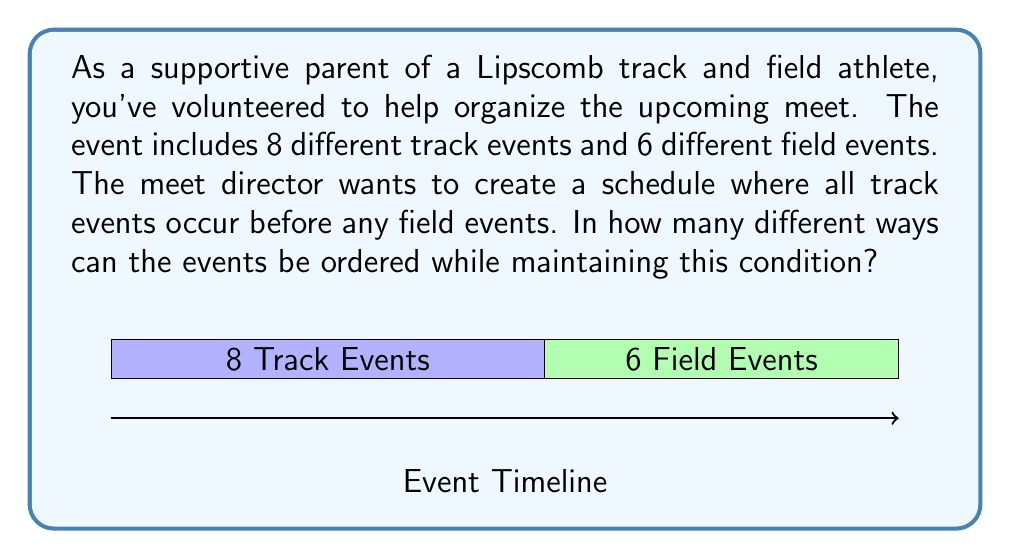Solve this math problem. Let's approach this step-by-step:

1) We need to arrange 8 track events followed by 6 field events.

2) This is a permutation problem, as the order matters.

3) For the track events:
   - We have 8 events to arrange
   - The number of ways to arrange 8 events is 8! (8 factorial)

4) For the field events:
   - We have 6 events to arrange
   - The number of ways to arrange 6 events is 6! (6 factorial)

5) According to the Multiplication Principle, if we have two independent events, we multiply their individual probabilities to get the total number of outcomes.

6) Therefore, the total number of different schedules is:

   $$8! \times 6!$$

7) Let's calculate this:
   $$8! \times 6! = (8 \times 7 \times 6 \times 5 \times 4 \times 3 \times 2 \times 1) \times (6 \times 5 \times 4 \times 3 \times 2 \times 1)$$
   $$= 40,320 \times 720 = 29,030,400$$

Thus, there are 29,030,400 different ways to schedule the events.
Answer: 29,030,400 